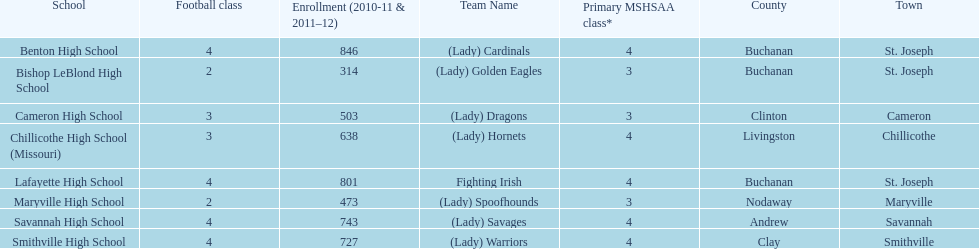Write the full table. {'header': ['School', 'Football class', 'Enrollment (2010-11 & 2011–12)', 'Team Name', 'Primary MSHSAA class*', 'County', 'Town'], 'rows': [['Benton High School', '4', '846', '(Lady) Cardinals', '4', 'Buchanan', 'St. Joseph'], ['Bishop LeBlond High School', '2', '314', '(Lady) Golden Eagles', '3', 'Buchanan', 'St. Joseph'], ['Cameron High School', '3', '503', '(Lady) Dragons', '3', 'Clinton', 'Cameron'], ['Chillicothe High School (Missouri)', '3', '638', '(Lady) Hornets', '4', 'Livingston', 'Chillicothe'], ['Lafayette High School', '4', '801', 'Fighting Irish', '4', 'Buchanan', 'St. Joseph'], ['Maryville High School', '2', '473', '(Lady) Spoofhounds', '3', 'Nodaway', 'Maryville'], ['Savannah High School', '4', '743', '(Lady) Savages', '4', 'Andrew', 'Savannah'], ['Smithville High School', '4', '727', '(Lady) Warriors', '4', 'Clay', 'Smithville']]} What is the number of football classes lafayette high school has? 4. 